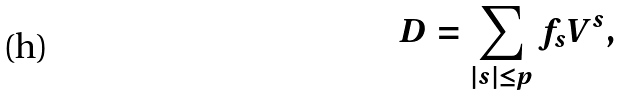Convert formula to latex. <formula><loc_0><loc_0><loc_500><loc_500>D = \sum _ { | s | \leq p } f _ { s } V ^ { s } ,</formula> 